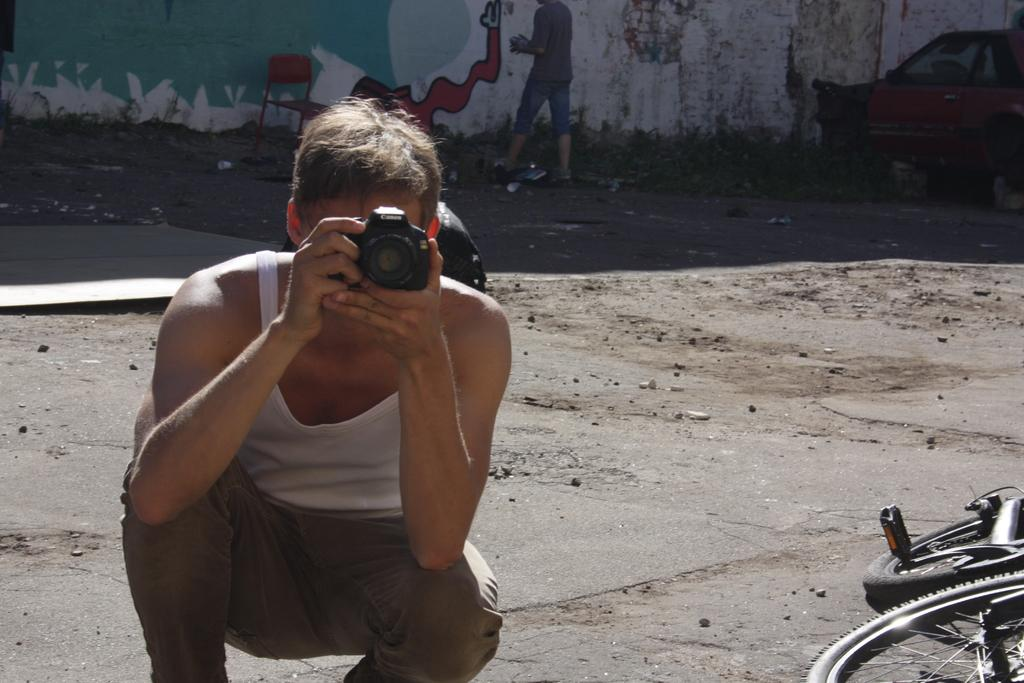What is the man in the image doing with the camera? The man is holding a camera and taking a picture. What else can be seen in the image besides the man with the camera? There is a chair, a bicycle, and another man standing in the image. Can you describe the position of the bicycle in the image? The bicycle is visible in the image, but its exact position is not clear from the provided facts. What does the man's mom wish for him while he is taking the picture? There is no information about the man's mom or her wishes in the image or the provided facts. 